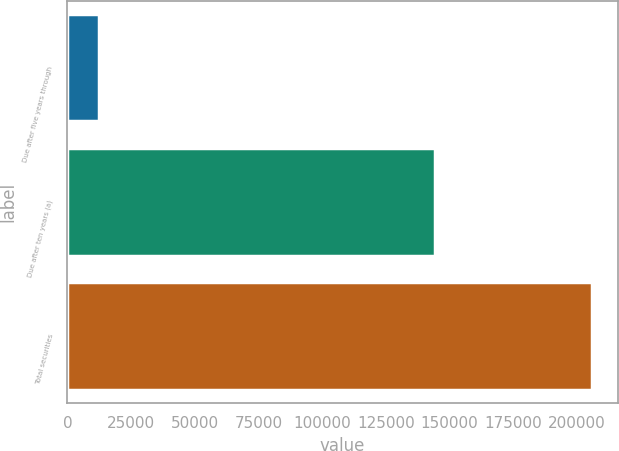Convert chart to OTSL. <chart><loc_0><loc_0><loc_500><loc_500><bar_chart><fcel>Due after five years through<fcel>Due after ten years (a)<fcel>Total securities<nl><fcel>12436<fcel>144342<fcel>205909<nl></chart> 